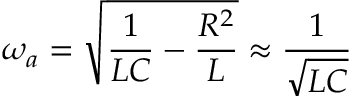Convert formula to latex. <formula><loc_0><loc_0><loc_500><loc_500>\omega _ { a } = \sqrt { \frac { 1 } { L C } - \frac { R ^ { 2 } } { L } } \approx \frac { 1 } { \sqrt { L C } }</formula> 